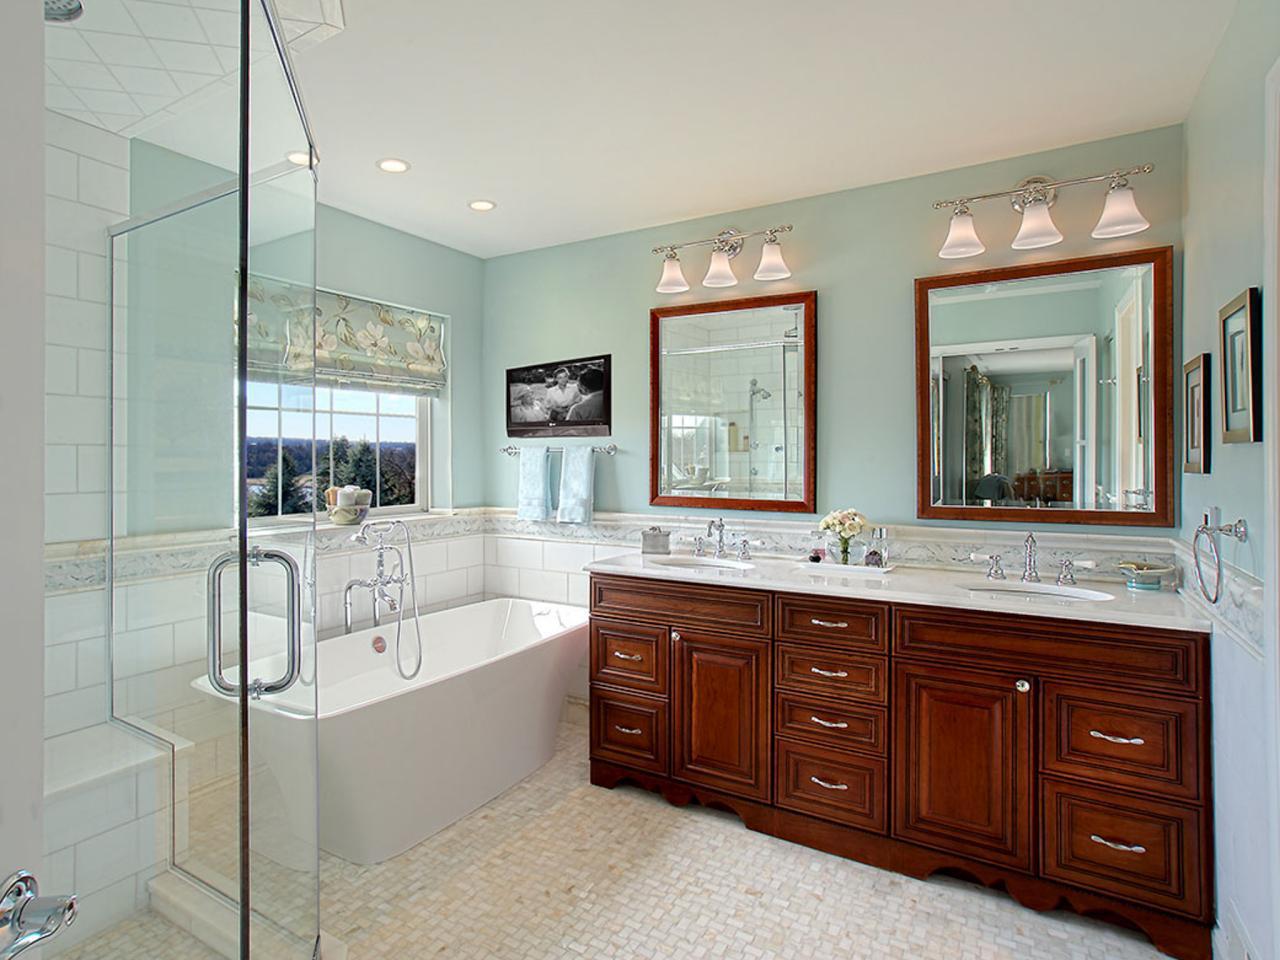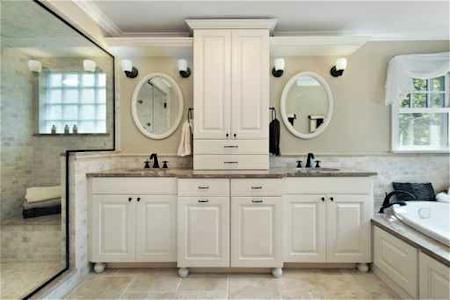The first image is the image on the left, the second image is the image on the right. Considering the images on both sides, is "The right image has two round mirrors on the wall above a bathroom sink." valid? Answer yes or no. Yes. The first image is the image on the left, the second image is the image on the right. Given the left and right images, does the statement "A bathroom includes two oval shapes on the wall flanking a white cabinet, with lights above the ovals." hold true? Answer yes or no. Yes. The first image is the image on the left, the second image is the image on the right. Assess this claim about the two images: "There is a single mirror over the counter in the image on the right.". Correct or not? Answer yes or no. No. 